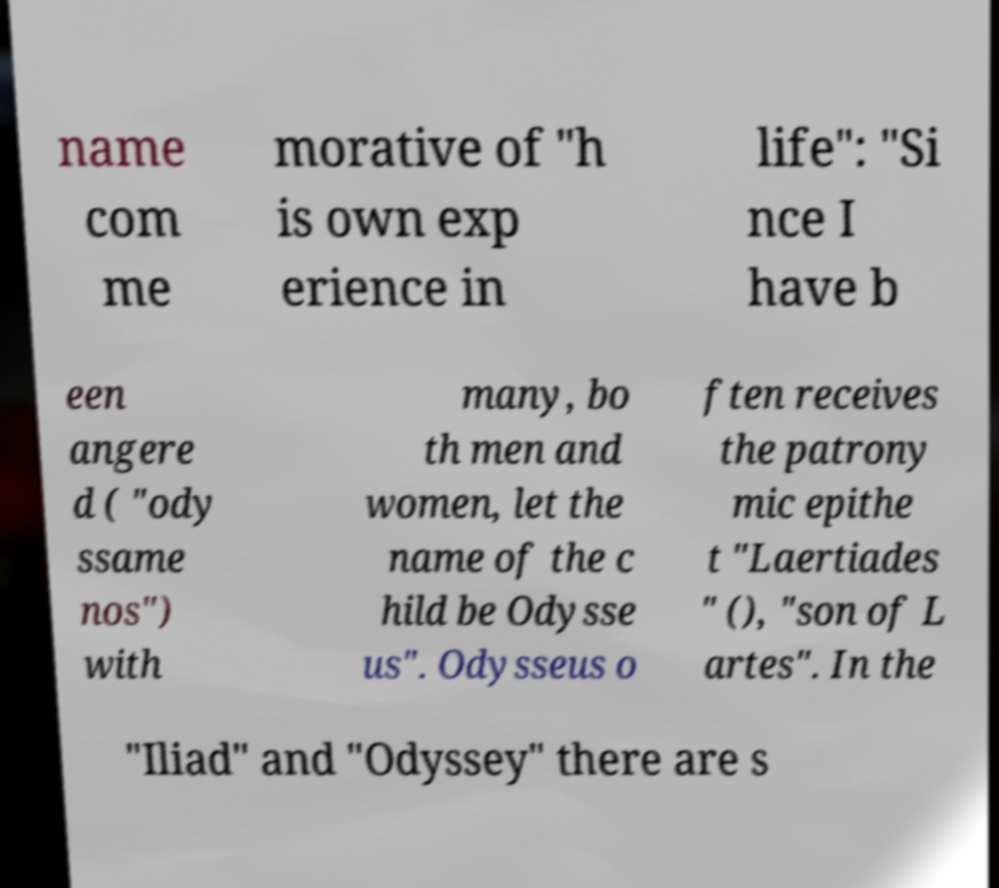Could you extract and type out the text from this image? name com me morative of "h is own exp erience in life": "Si nce I have b een angere d ( "ody ssame nos") with many, bo th men and women, let the name of the c hild be Odysse us". Odysseus o ften receives the patrony mic epithe t "Laertiades " (), "son of L artes". In the "Iliad" and "Odyssey" there are s 